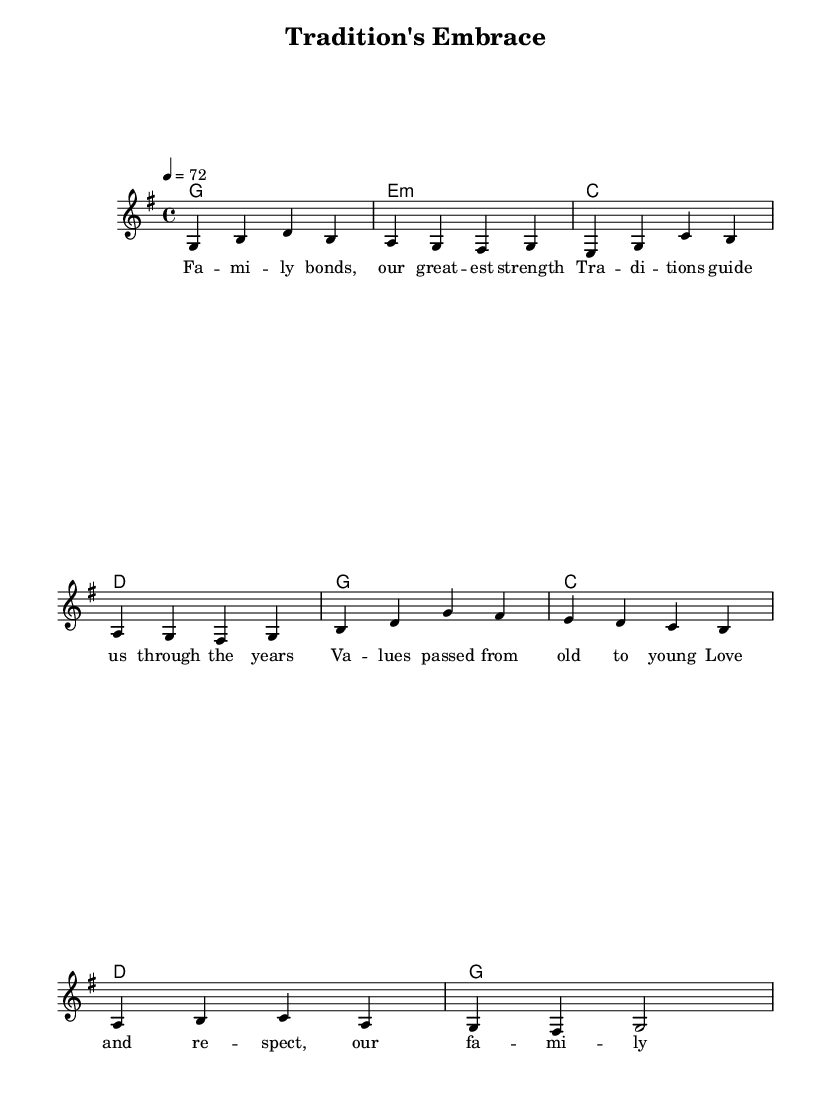What is the key signature of this music? The key signature is G major, which has one sharp (F#). The presence of the F# in the melody indicates that the music is in G major.
Answer: G major What is the time signature of this music? The time signature is 4/4, meaning there are four beats in each measure and the quarter note gets one beat. You can identify this from the notation at the beginning of the score.
Answer: 4/4 What is the tempo marking for this piece? The tempo marking is indicated as 4 = 72, which means there should be 72 quarter note beats per minute. This information is found at the beginning of the score under the global settings.
Answer: 72 How many measures are in the melody? The melody consists of 8 measures, as indicated by the grouping of the notes and bars in the melody line. Counting the bar lines from start to finish confirms that there are a total of 8 measures.
Answer: 8 What are the first two lyrics of the song? The lyrics start with "Fa -- mi", which is specified in the lyric mode after the melody. The first two words can be directly identified by reading the initial line of the lyrics.
Answer: Fa -- mi What is the overall theme of this K-Pop ballad? The overall theme revolves around family values and traditions, as indicated by lyrics mentioning family bonds, love, and respect. This theme resonates with conservative ideals focused on familial connections and traditions.
Answer: Family values Which chords are used in the harmonies section? The chords used in the harmonies section are G, E minor, C, and D. These can be identified by examining the chord mode section, where the chords are explicitly listed in sequence.
Answer: G, E minor, C, D 